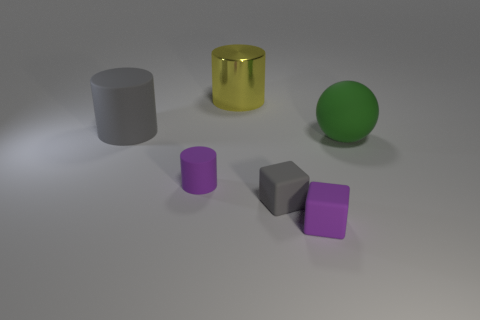Do the cube to the left of the tiny purple cube and the yellow thing have the same material?
Offer a very short reply. No. What is the size of the block that is the same color as the small rubber cylinder?
Offer a terse response. Small. How many purple cylinders are the same size as the yellow shiny object?
Your answer should be very brief. 0. Are there the same number of big rubber balls that are to the left of the big yellow metal cylinder and purple blocks?
Your answer should be compact. No. What number of large things are on the right side of the purple cylinder and in front of the yellow thing?
Make the answer very short. 1. The green ball that is made of the same material as the purple cylinder is what size?
Provide a succinct answer. Large. How many other matte objects are the same shape as the large green matte object?
Your answer should be very brief. 0. Are there more gray matte cubes that are on the right side of the small purple cube than tiny shiny blocks?
Your response must be concise. No. What shape is the object that is both right of the tiny gray object and on the left side of the rubber ball?
Offer a terse response. Cube. Do the green rubber ball and the yellow cylinder have the same size?
Offer a very short reply. Yes. 